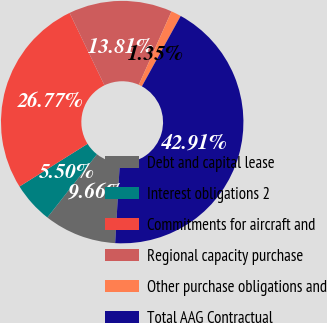Convert chart to OTSL. <chart><loc_0><loc_0><loc_500><loc_500><pie_chart><fcel>Debt and capital lease<fcel>Interest obligations 2<fcel>Commitments for aircraft and<fcel>Regional capacity purchase<fcel>Other purchase obligations and<fcel>Total AAG Contractual<nl><fcel>9.66%<fcel>5.5%<fcel>26.77%<fcel>13.81%<fcel>1.35%<fcel>42.91%<nl></chart> 